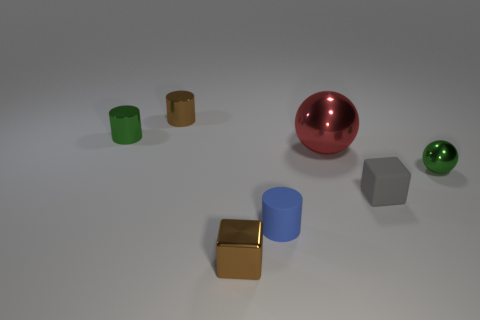Does the tiny brown object that is behind the gray object have the same material as the big thing? Based on the image, the tiny brown object appears similar in texture and sheen to both the blue cylinder and golden cube in front of it, suggesting that it could be made of a similar plastic or metal material. However, without additional context or tactile confirmation, it is difficult to determine with absolute certainty. The large red sphere seems to have a more reflective surface, indicative of a polished metal, whereas the tiny brown object has a less reflective, matte finish. 